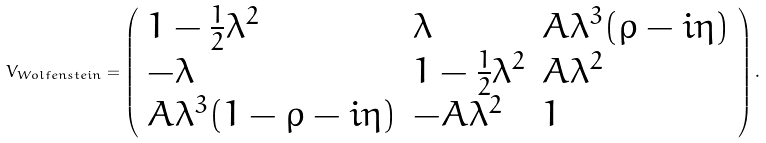Convert formula to latex. <formula><loc_0><loc_0><loc_500><loc_500>V _ { W o l f e n s t e i n } = \left ( \begin{array} { l l l } 1 - \frac { 1 } { 2 } \lambda ^ { 2 } & \lambda & A \lambda ^ { 3 } ( \rho - i \eta ) \\ - \lambda & 1 - \frac { 1 } { 2 } \lambda ^ { 2 } & A \lambda ^ { 2 } \\ A \lambda ^ { 3 } ( 1 - \rho - i \eta ) & - A \lambda ^ { 2 } & 1 \end{array} \right ) .</formula> 